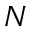Convert formula to latex. <formula><loc_0><loc_0><loc_500><loc_500>N</formula> 